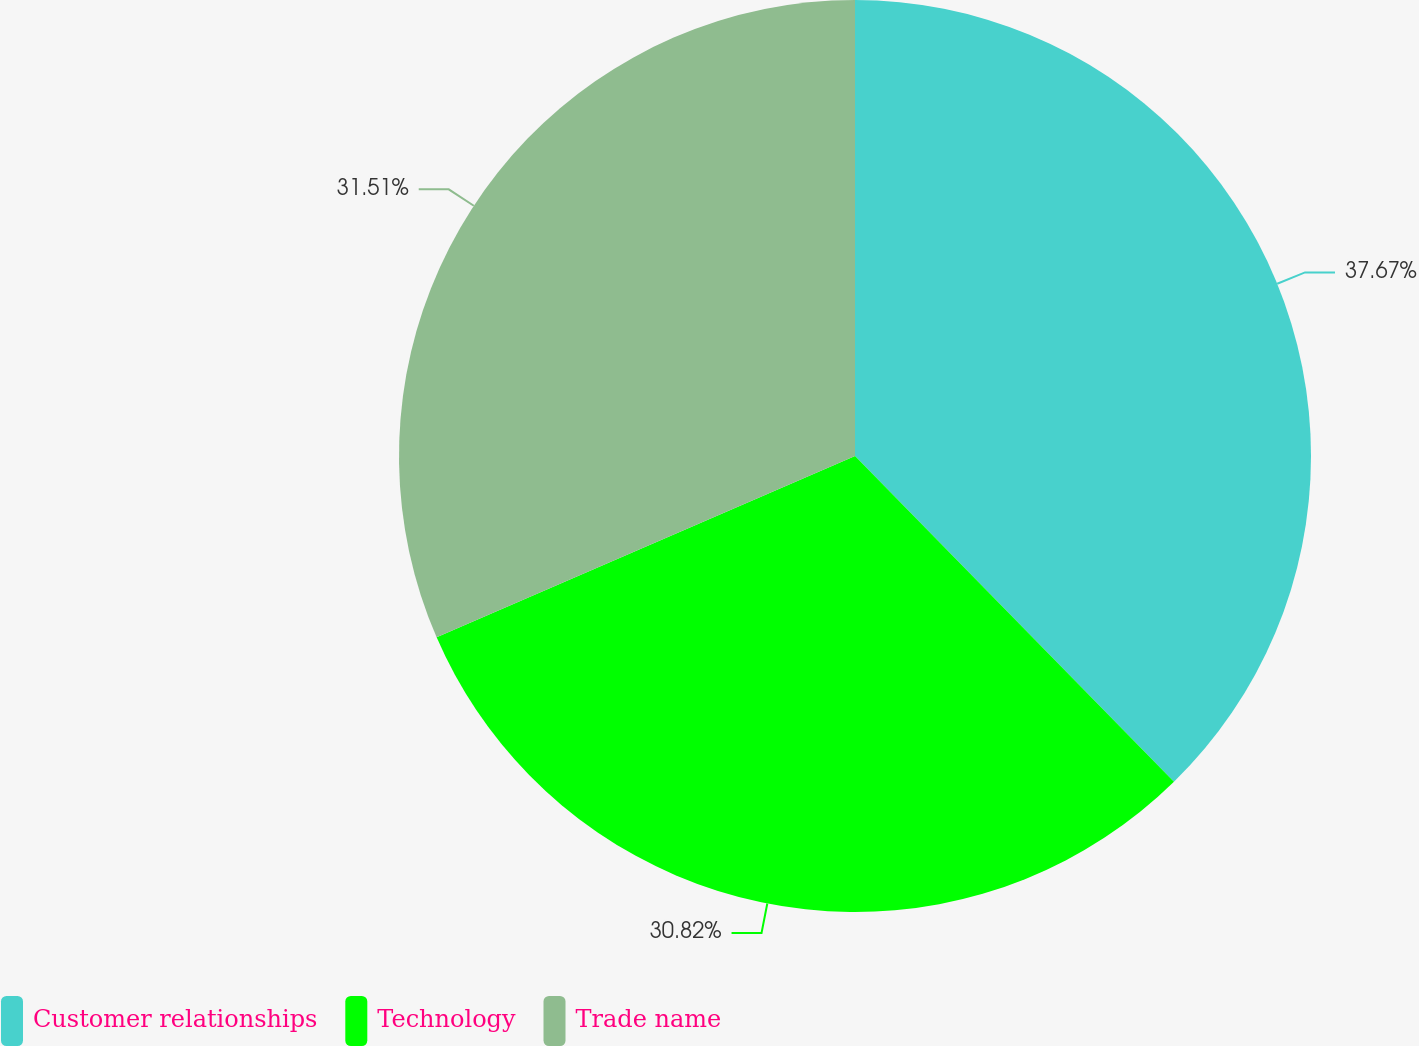Convert chart to OTSL. <chart><loc_0><loc_0><loc_500><loc_500><pie_chart><fcel>Customer relationships<fcel>Technology<fcel>Trade name<nl><fcel>37.67%<fcel>30.82%<fcel>31.51%<nl></chart> 